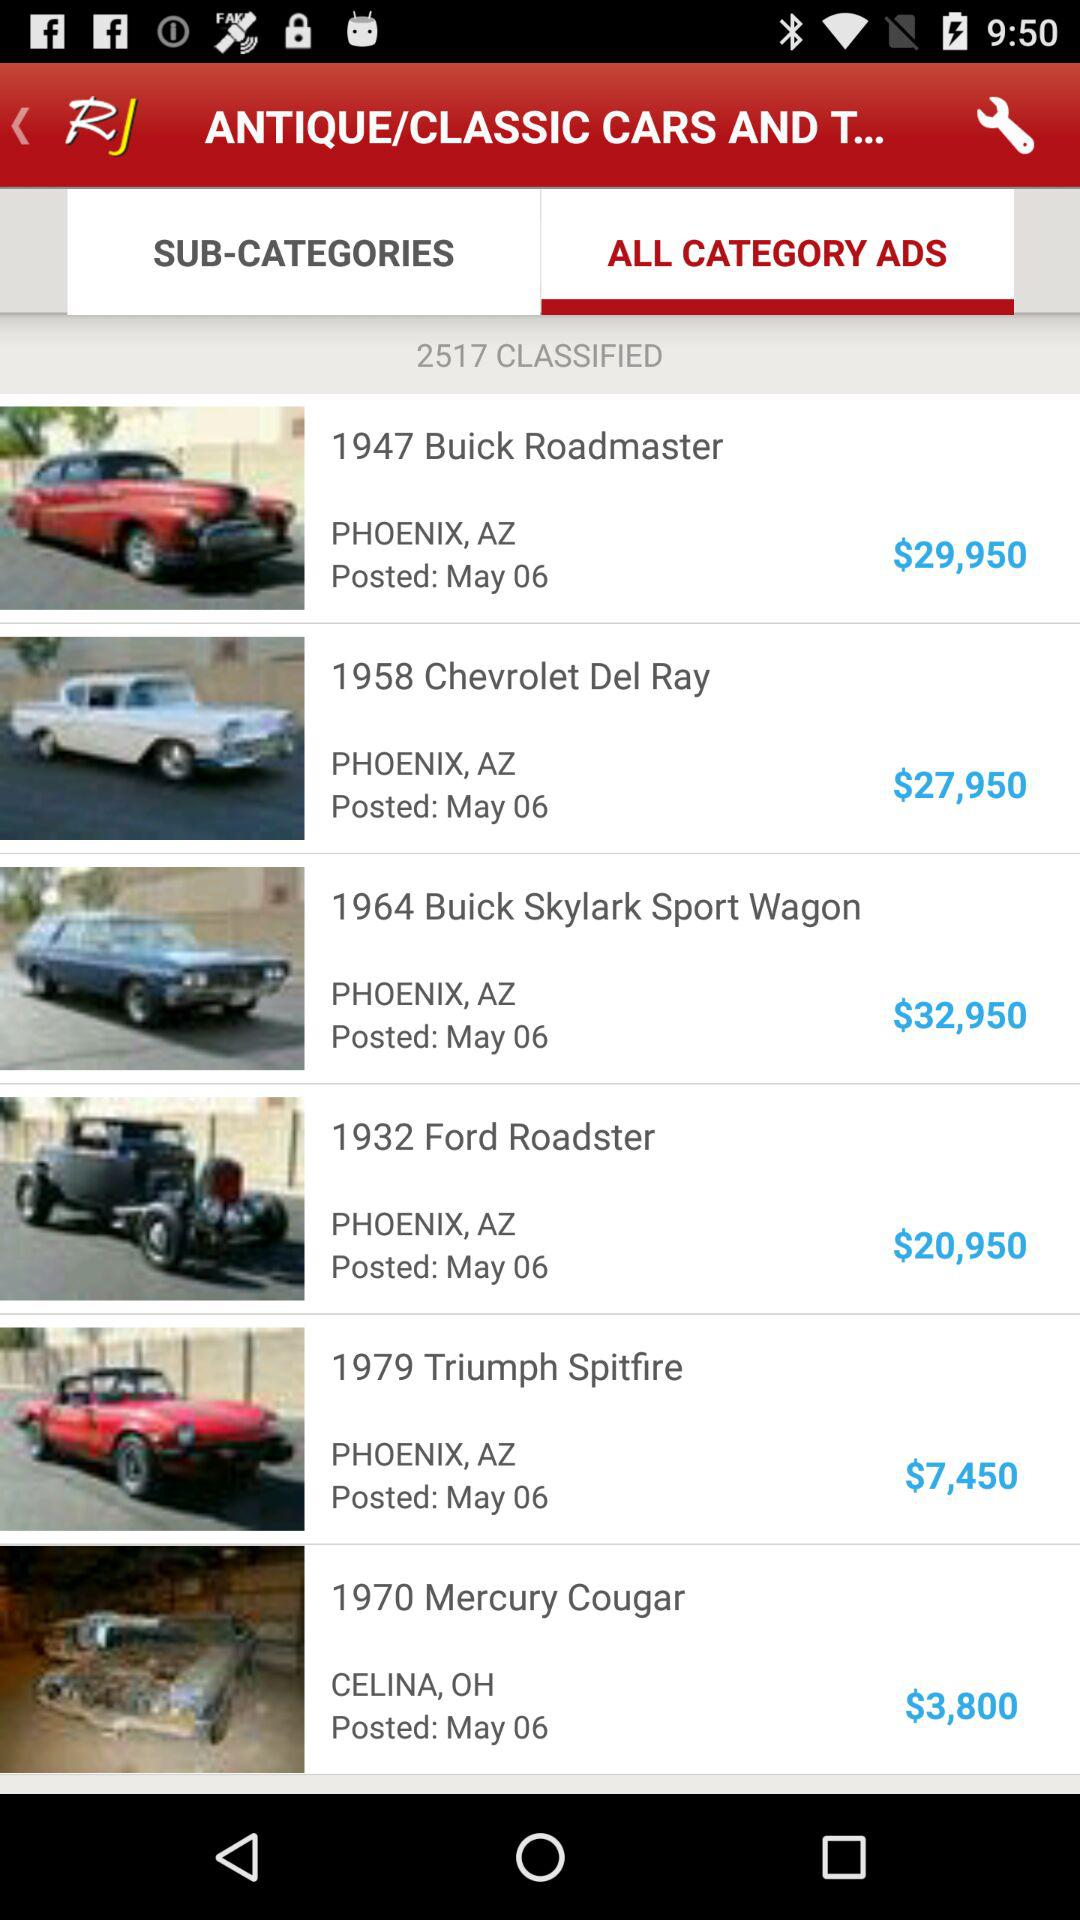What is the price of a "Skylark Sport Wagon"? The price is $32,950. 